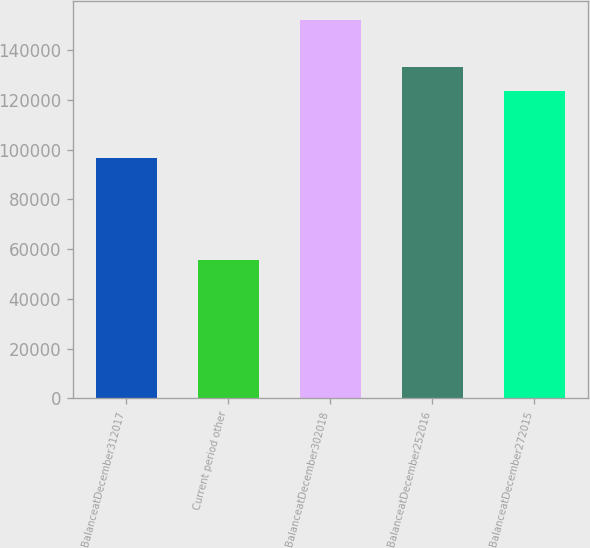Convert chart to OTSL. <chart><loc_0><loc_0><loc_500><loc_500><bar_chart><fcel>BalanceatDecember312017<fcel>Current period other<fcel>BalanceatDecember302018<fcel>BalanceatDecember252016<fcel>BalanceatDecember272015<nl><fcel>96661<fcel>55524<fcel>152185<fcel>133311<fcel>123645<nl></chart> 